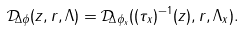<formula> <loc_0><loc_0><loc_500><loc_500>\mathcal { D } _ { \Delta \phi } ( z , r , \Lambda ) = \mathcal { D } _ { \Delta \phi _ { x } } ( ( \tau _ { x } ) ^ { - 1 } ( z ) , r , \Lambda _ { x } ) .</formula> 